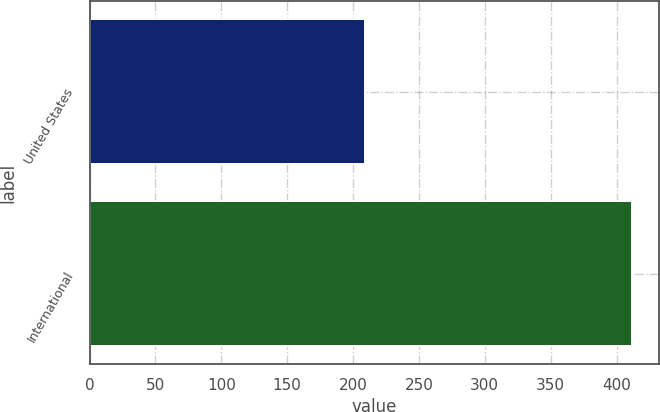<chart> <loc_0><loc_0><loc_500><loc_500><bar_chart><fcel>United States<fcel>International<nl><fcel>209.2<fcel>411.4<nl></chart> 